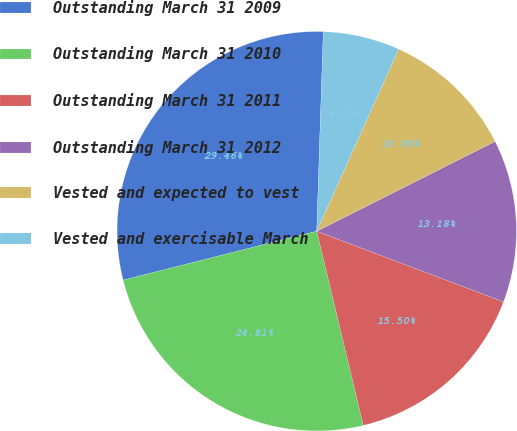Convert chart to OTSL. <chart><loc_0><loc_0><loc_500><loc_500><pie_chart><fcel>Outstanding March 31 2009<fcel>Outstanding March 31 2010<fcel>Outstanding March 31 2011<fcel>Outstanding March 31 2012<fcel>Vested and expected to vest<fcel>Vested and exercisable March<nl><fcel>29.46%<fcel>24.81%<fcel>15.5%<fcel>13.18%<fcel>10.85%<fcel>6.2%<nl></chart> 